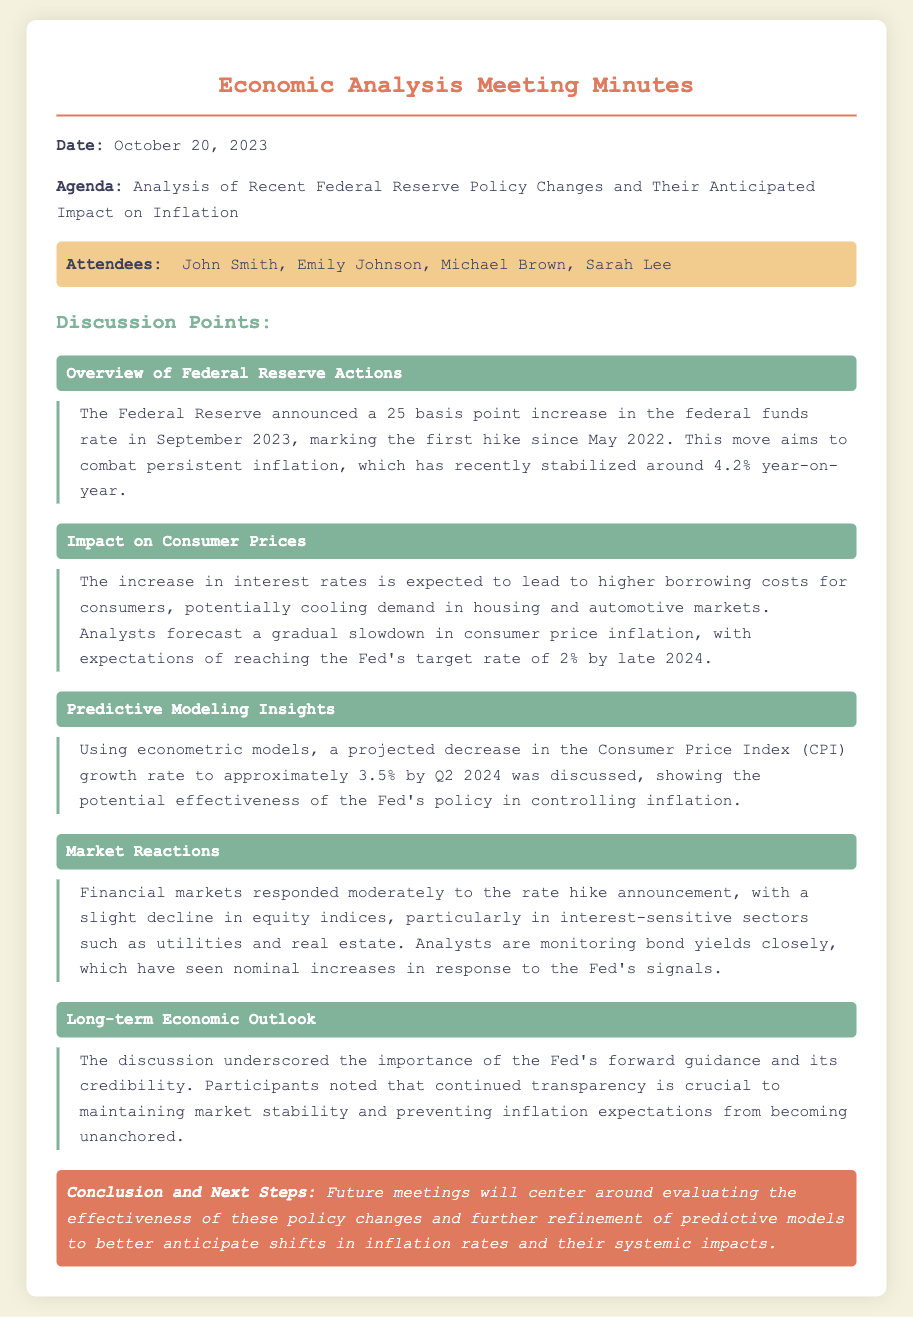What was the date of the meeting? The date of the meeting is specified at the beginning of the document.
Answer: October 20, 2023 Who announced the recent interest rate hike? The document refers to the Federal Reserve's announcement regarding the interest rate hike.
Answer: Federal Reserve What was the increase in the federal funds rate? The document explicitly states the amount of the rate increase that occurred.
Answer: 25 basis points What is the expected consumer price inflation rate by late 2024? The document provides a forecast for the consumer price inflation rate.
Answer: 2% What is the projected CPI growth rate by Q2 2024? The document discusses the predicted decrease in the CPI growth rate based on econometric models.
Answer: 3.5% What sectors saw a decline in equity indices after the rate hike announcement? The document mentions specific sectors reacting to the announcement of the rate hike.
Answer: Utilities and real estate Why is transparency important according to the discussion? The document highlights a key theme discussed in relation to market stability and inflation expectations.
Answer: Maintaining market stability What will future meetings focus on? The conclusion summarizes the focus of upcoming meetings as highlighted in the minutes.
Answer: Evaluating the effectiveness of policy changes 